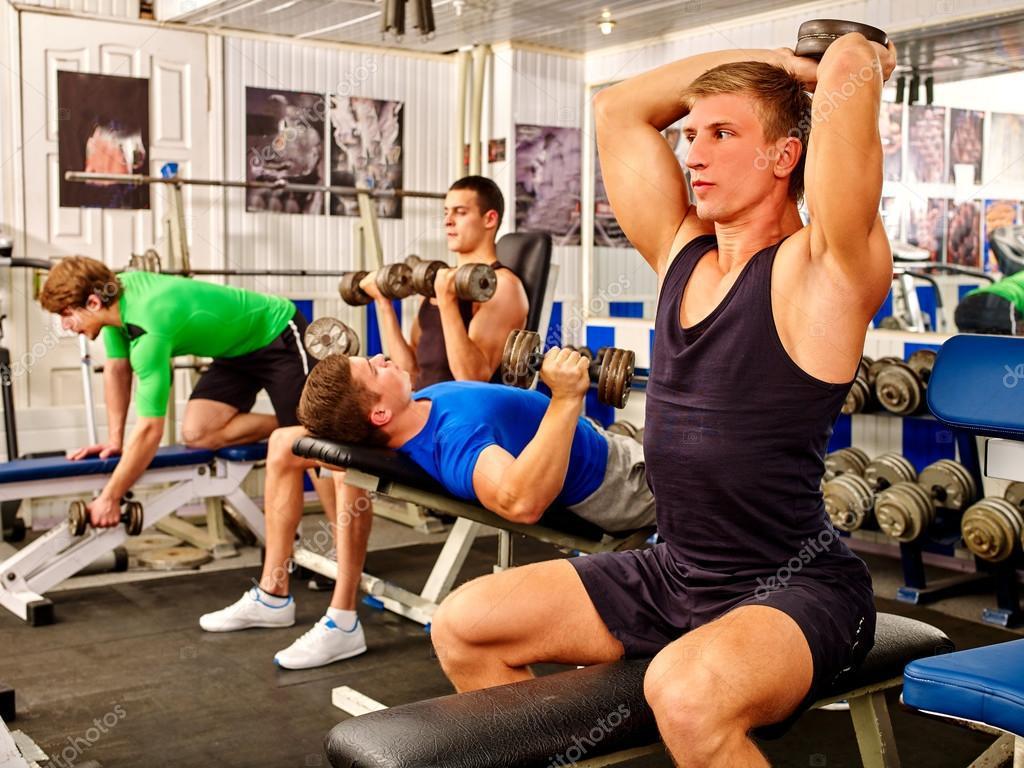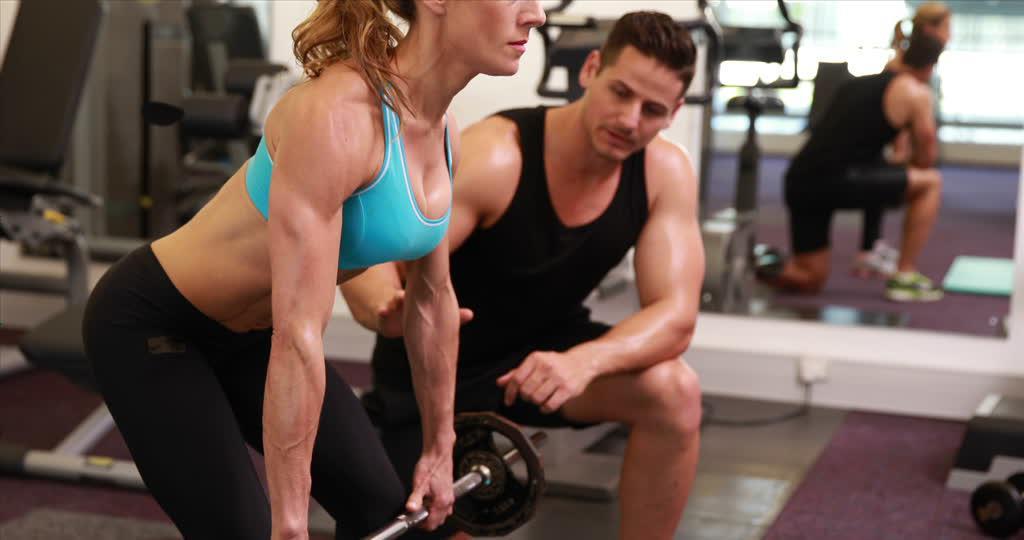The first image is the image on the left, the second image is the image on the right. Given the left and right images, does the statement "The left and right image contains the same number of people working out." hold true? Answer yes or no. No. The first image is the image on the left, the second image is the image on the right. Examine the images to the left and right. Is the description "A person is holding a weight above their head." accurate? Answer yes or no. Yes. 